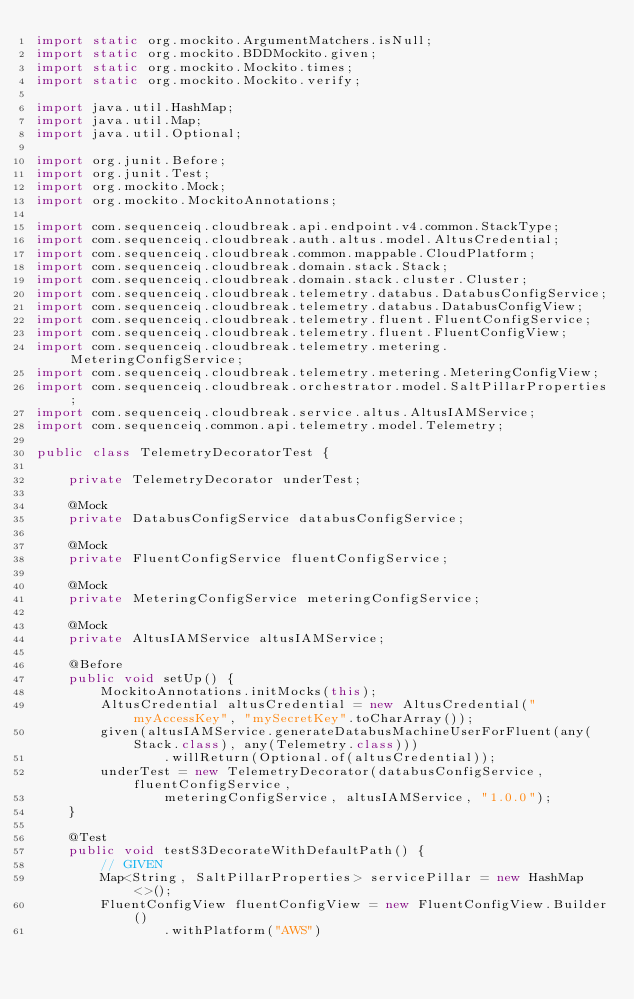<code> <loc_0><loc_0><loc_500><loc_500><_Java_>import static org.mockito.ArgumentMatchers.isNull;
import static org.mockito.BDDMockito.given;
import static org.mockito.Mockito.times;
import static org.mockito.Mockito.verify;

import java.util.HashMap;
import java.util.Map;
import java.util.Optional;

import org.junit.Before;
import org.junit.Test;
import org.mockito.Mock;
import org.mockito.MockitoAnnotations;

import com.sequenceiq.cloudbreak.api.endpoint.v4.common.StackType;
import com.sequenceiq.cloudbreak.auth.altus.model.AltusCredential;
import com.sequenceiq.cloudbreak.common.mappable.CloudPlatform;
import com.sequenceiq.cloudbreak.domain.stack.Stack;
import com.sequenceiq.cloudbreak.domain.stack.cluster.Cluster;
import com.sequenceiq.cloudbreak.telemetry.databus.DatabusConfigService;
import com.sequenceiq.cloudbreak.telemetry.databus.DatabusConfigView;
import com.sequenceiq.cloudbreak.telemetry.fluent.FluentConfigService;
import com.sequenceiq.cloudbreak.telemetry.fluent.FluentConfigView;
import com.sequenceiq.cloudbreak.telemetry.metering.MeteringConfigService;
import com.sequenceiq.cloudbreak.telemetry.metering.MeteringConfigView;
import com.sequenceiq.cloudbreak.orchestrator.model.SaltPillarProperties;
import com.sequenceiq.cloudbreak.service.altus.AltusIAMService;
import com.sequenceiq.common.api.telemetry.model.Telemetry;

public class TelemetryDecoratorTest {

    private TelemetryDecorator underTest;

    @Mock
    private DatabusConfigService databusConfigService;

    @Mock
    private FluentConfigService fluentConfigService;

    @Mock
    private MeteringConfigService meteringConfigService;

    @Mock
    private AltusIAMService altusIAMService;

    @Before
    public void setUp() {
        MockitoAnnotations.initMocks(this);
        AltusCredential altusCredential = new AltusCredential("myAccessKey", "mySecretKey".toCharArray());
        given(altusIAMService.generateDatabusMachineUserForFluent(any(Stack.class), any(Telemetry.class)))
                .willReturn(Optional.of(altusCredential));
        underTest = new TelemetryDecorator(databusConfigService, fluentConfigService,
                meteringConfigService, altusIAMService, "1.0.0");
    }

    @Test
    public void testS3DecorateWithDefaultPath() {
        // GIVEN
        Map<String, SaltPillarProperties> servicePillar = new HashMap<>();
        FluentConfigView fluentConfigView = new FluentConfigView.Builder()
                .withPlatform("AWS")</code> 